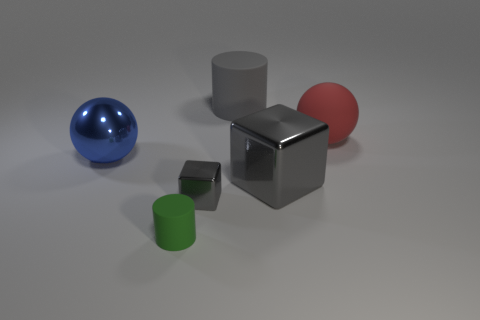What materials do the objects in the image seem to be made of? The objects present varying materials: the blue and red spheres have a glossy finish suggesting a material like plastic or polished metal; the grey cube appears metallic with a reflective surface; the green cylinder looks like matte plastic; and the smaller cube has a brushed metal finish. 